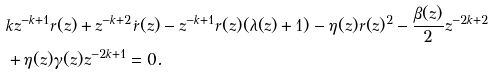Convert formula to latex. <formula><loc_0><loc_0><loc_500><loc_500>& k z ^ { - k + 1 } r ( z ) + z ^ { - k + 2 } \dot { r } ( z ) - z ^ { - k + 1 } r ( z ) ( \lambda ( z ) + 1 ) - \eta ( z ) r ( z ) ^ { 2 } - \frac { \beta ( z ) } { 2 } z ^ { - 2 k + 2 } \\ & + \eta ( z ) \gamma ( z ) z ^ { - 2 k + 1 } = 0 .</formula> 